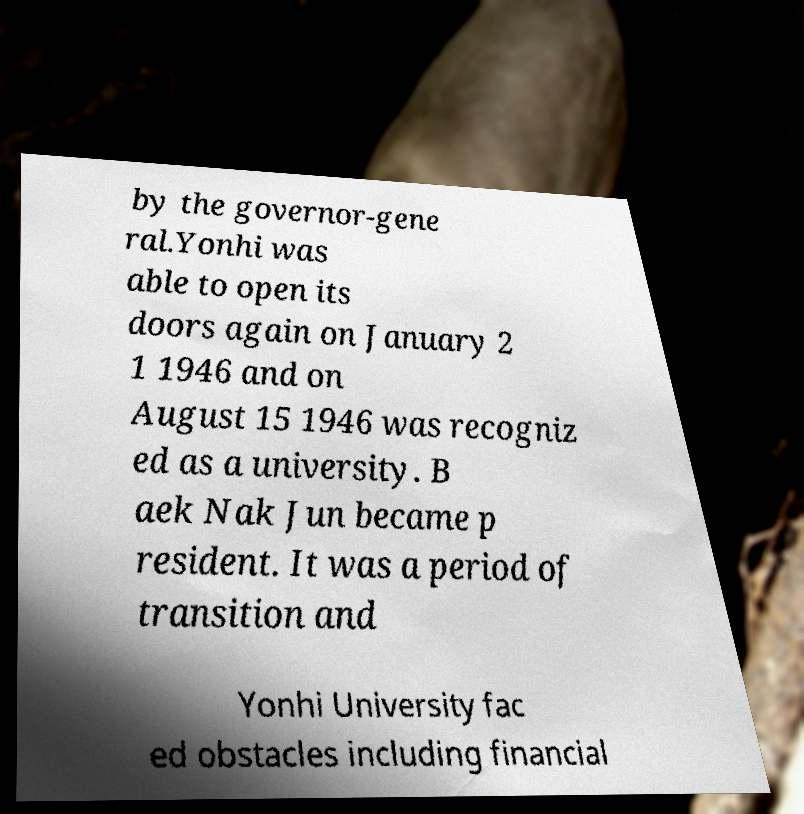There's text embedded in this image that I need extracted. Can you transcribe it verbatim? by the governor-gene ral.Yonhi was able to open its doors again on January 2 1 1946 and on August 15 1946 was recogniz ed as a university. B aek Nak Jun became p resident. It was a period of transition and Yonhi University fac ed obstacles including financial 